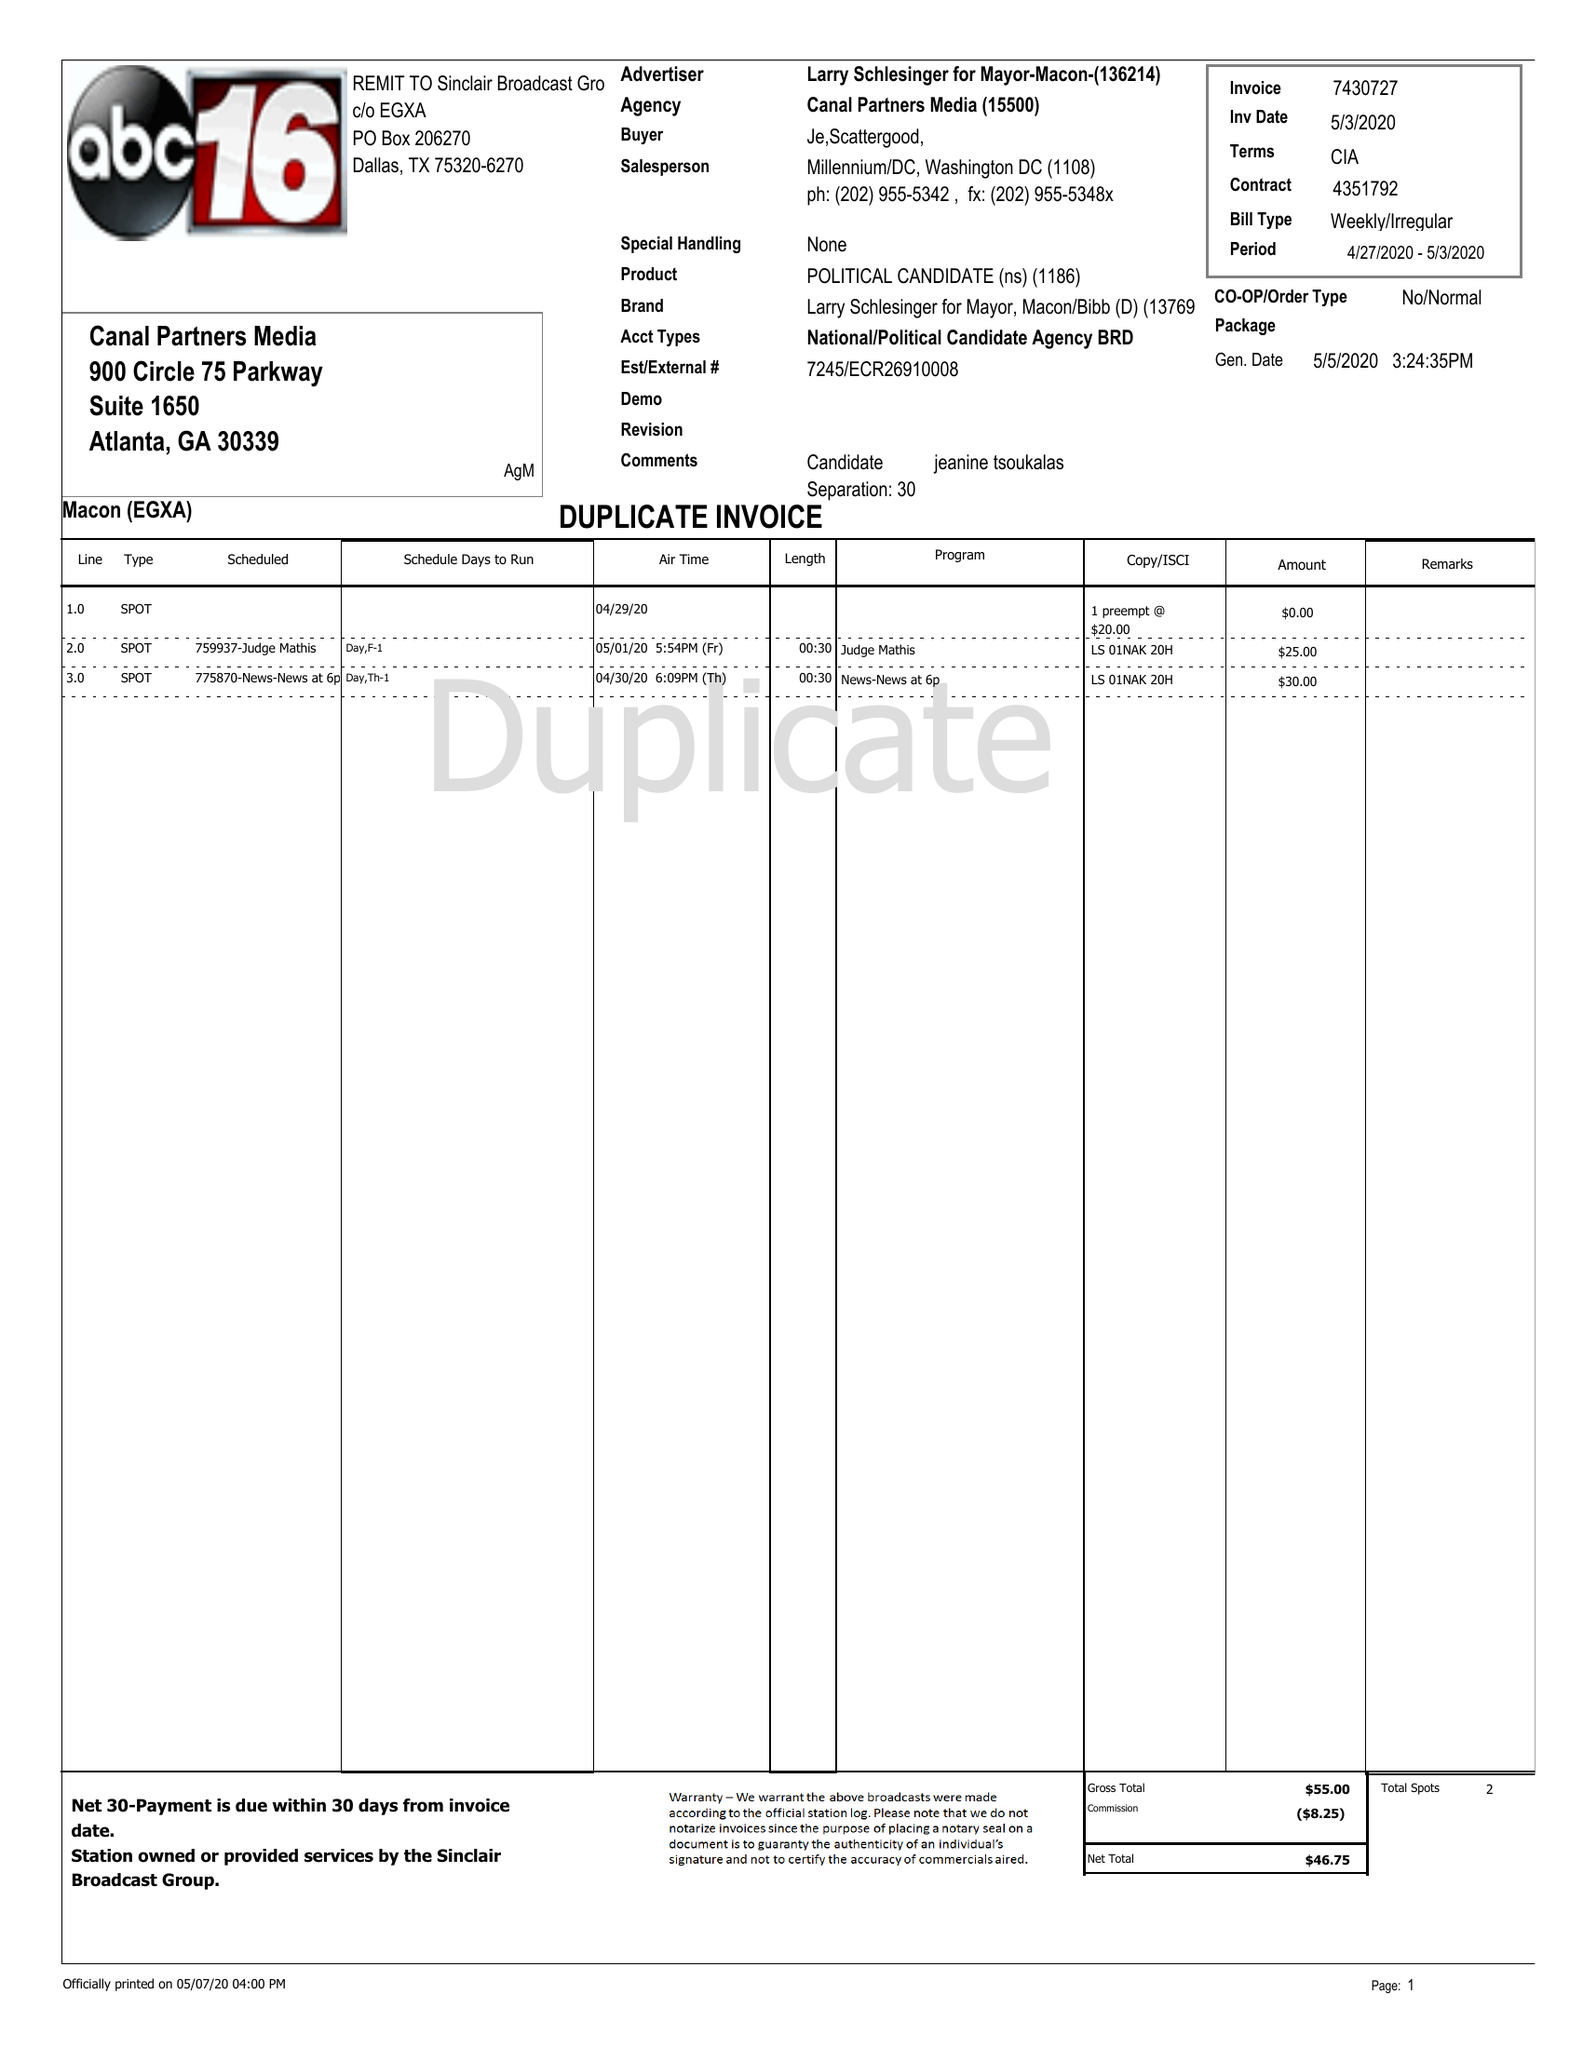What is the value for the advertiser?
Answer the question using a single word or phrase. LARRY SCHLESINGER FOR MAYOR-MACON- 